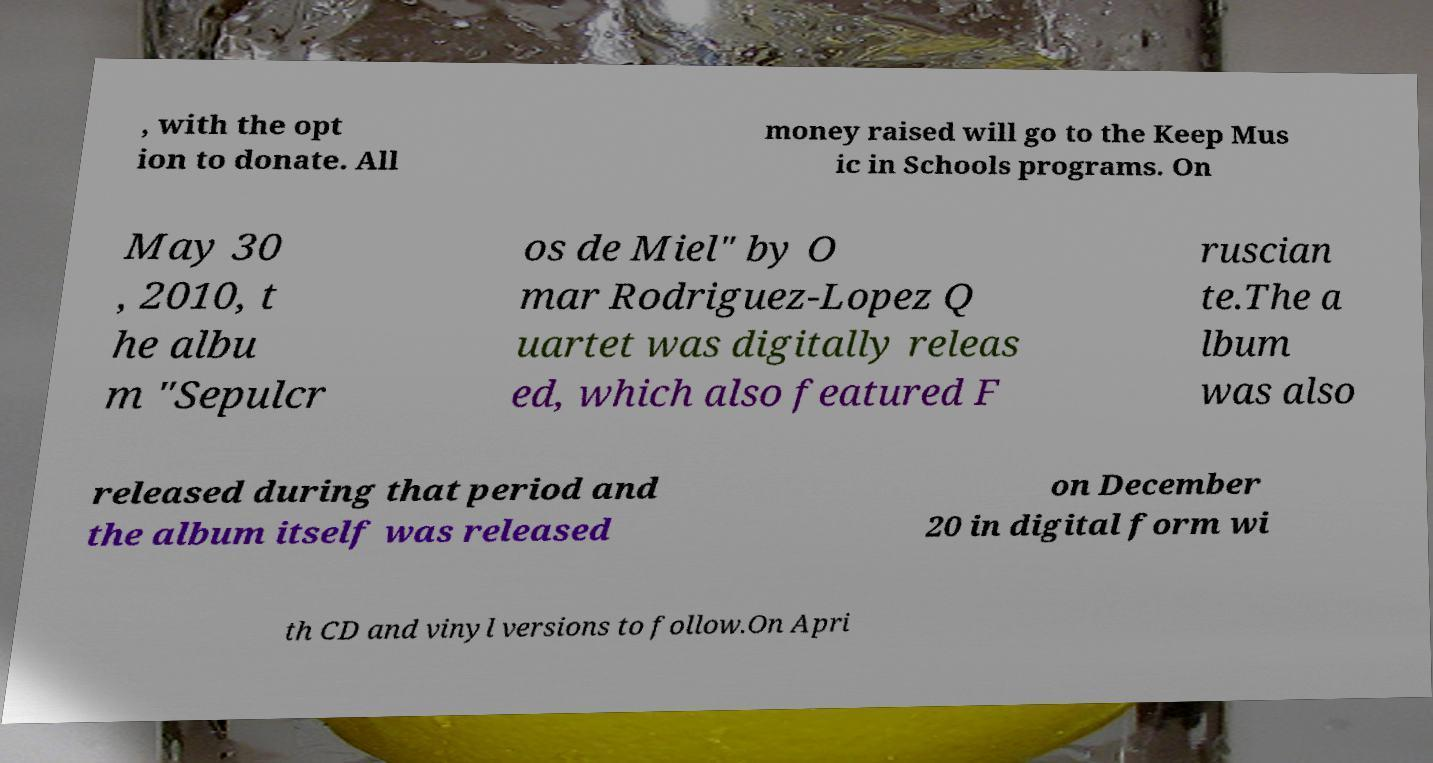Can you accurately transcribe the text from the provided image for me? , with the opt ion to donate. All money raised will go to the Keep Mus ic in Schools programs. On May 30 , 2010, t he albu m "Sepulcr os de Miel" by O mar Rodriguez-Lopez Q uartet was digitally releas ed, which also featured F ruscian te.The a lbum was also released during that period and the album itself was released on December 20 in digital form wi th CD and vinyl versions to follow.On Apri 